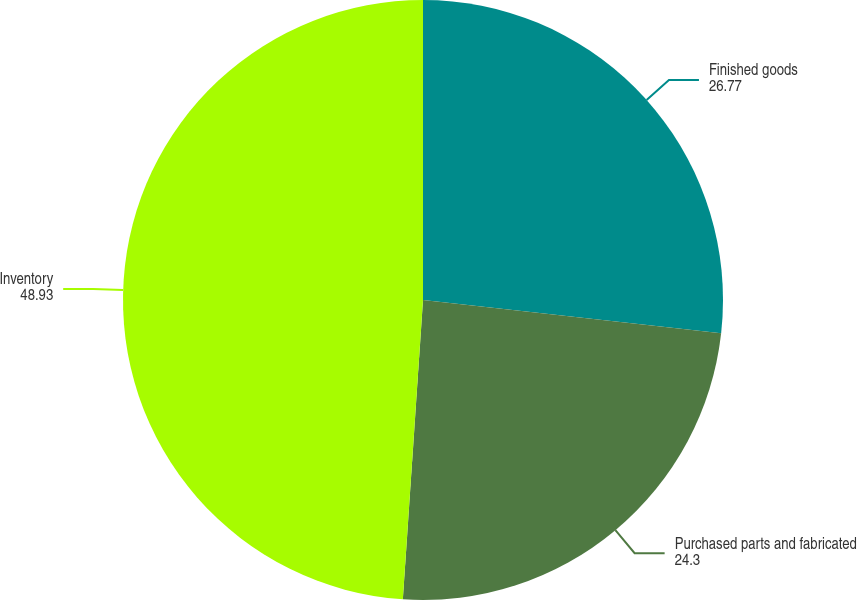Convert chart to OTSL. <chart><loc_0><loc_0><loc_500><loc_500><pie_chart><fcel>Finished goods<fcel>Purchased parts and fabricated<fcel>Inventory<nl><fcel>26.77%<fcel>24.3%<fcel>48.93%<nl></chart> 